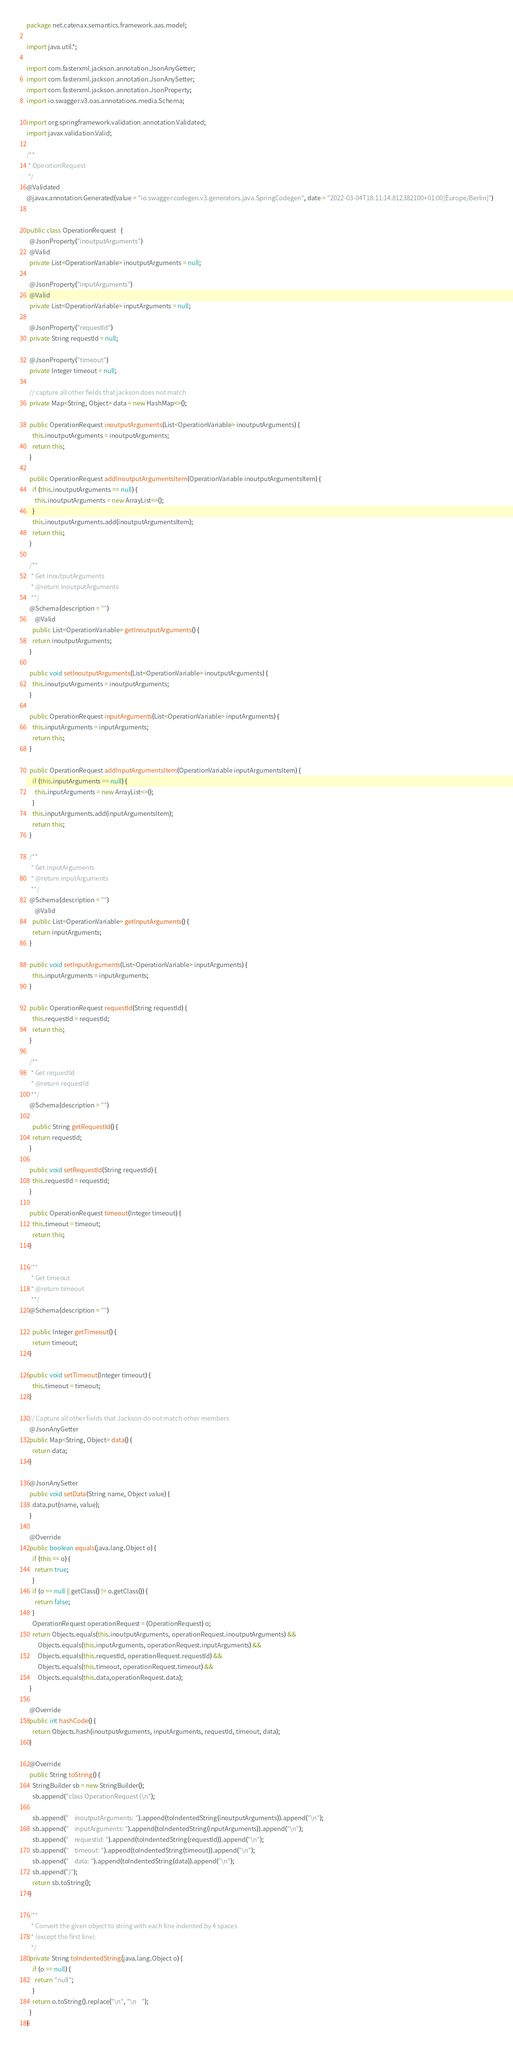Convert code to text. <code><loc_0><loc_0><loc_500><loc_500><_Java_>package net.catenax.semantics.framework.aas.model;

import java.util.*;

import com.fasterxml.jackson.annotation.JsonAnyGetter;
import com.fasterxml.jackson.annotation.JsonAnySetter;
import com.fasterxml.jackson.annotation.JsonProperty;
import io.swagger.v3.oas.annotations.media.Schema;

import org.springframework.validation.annotation.Validated;
import javax.validation.Valid;

/**
 * OperationRequest
 */
@Validated
@javax.annotation.Generated(value = "io.swagger.codegen.v3.generators.java.SpringCodegen", date = "2022-03-04T18:11:14.812382100+01:00[Europe/Berlin]")


public class OperationRequest   {
  @JsonProperty("inoutputArguments")
  @Valid
  private List<OperationVariable> inoutputArguments = null;

  @JsonProperty("inputArguments")
  @Valid
  private List<OperationVariable> inputArguments = null;

  @JsonProperty("requestId")
  private String requestId = null;

  @JsonProperty("timeout")
  private Integer timeout = null;

  // capture all other fields that jackson does not match
  private Map<String, Object> data = new HashMap<>();

  public OperationRequest inoutputArguments(List<OperationVariable> inoutputArguments) {
    this.inoutputArguments = inoutputArguments;
    return this;
  }

  public OperationRequest addInoutputArgumentsItem(OperationVariable inoutputArgumentsItem) {
    if (this.inoutputArguments == null) {
      this.inoutputArguments = new ArrayList<>();
    }
    this.inoutputArguments.add(inoutputArgumentsItem);
    return this;
  }

  /**
   * Get inoutputArguments
   * @return inoutputArguments
   **/
  @Schema(description = "")
      @Valid
    public List<OperationVariable> getInoutputArguments() {
    return inoutputArguments;
  }

  public void setInoutputArguments(List<OperationVariable> inoutputArguments) {
    this.inoutputArguments = inoutputArguments;
  }

  public OperationRequest inputArguments(List<OperationVariable> inputArguments) {
    this.inputArguments = inputArguments;
    return this;
  }

  public OperationRequest addInputArgumentsItem(OperationVariable inputArgumentsItem) {
    if (this.inputArguments == null) {
      this.inputArguments = new ArrayList<>();
    }
    this.inputArguments.add(inputArgumentsItem);
    return this;
  }

  /**
   * Get inputArguments
   * @return inputArguments
   **/
  @Schema(description = "")
      @Valid
    public List<OperationVariable> getInputArguments() {
    return inputArguments;
  }

  public void setInputArguments(List<OperationVariable> inputArguments) {
    this.inputArguments = inputArguments;
  }

  public OperationRequest requestId(String requestId) {
    this.requestId = requestId;
    return this;
  }

  /**
   * Get requestId
   * @return requestId
   **/
  @Schema(description = "")
  
    public String getRequestId() {
    return requestId;
  }

  public void setRequestId(String requestId) {
    this.requestId = requestId;
  }

  public OperationRequest timeout(Integer timeout) {
    this.timeout = timeout;
    return this;
  }

  /**
   * Get timeout
   * @return timeout
   **/
  @Schema(description = "")
  
    public Integer getTimeout() {
    return timeout;
  }

  public void setTimeout(Integer timeout) {
    this.timeout = timeout;
  }

  // Capture all other fields that Jackson do not match other members
  @JsonAnyGetter
  public Map<String, Object> data() {
    return data;
  }

  @JsonAnySetter
  public void setData(String name, Object value) {
    data.put(name, value);
  }

  @Override
  public boolean equals(java.lang.Object o) {
    if (this == o) {
      return true;
    }
    if (o == null || getClass() != o.getClass()) {
      return false;
    }
    OperationRequest operationRequest = (OperationRequest) o;
    return Objects.equals(this.inoutputArguments, operationRequest.inoutputArguments) &&
        Objects.equals(this.inputArguments, operationRequest.inputArguments) &&
        Objects.equals(this.requestId, operationRequest.requestId) &&
        Objects.equals(this.timeout, operationRequest.timeout) &&
        Objects.equals(this.data,operationRequest.data);
  }

  @Override
  public int hashCode() {
    return Objects.hash(inoutputArguments, inputArguments, requestId, timeout, data);
  }

  @Override
  public String toString() {
    StringBuilder sb = new StringBuilder();
    sb.append("class OperationRequest {\n");
    
    sb.append("    inoutputArguments: ").append(toIndentedString(inoutputArguments)).append("\n");
    sb.append("    inputArguments: ").append(toIndentedString(inputArguments)).append("\n");
    sb.append("    requestId: ").append(toIndentedString(requestId)).append("\n");
    sb.append("    timeout: ").append(toIndentedString(timeout)).append("\n");
    sb.append("    data: ").append(toIndentedString(data)).append("\n");
    sb.append("}");
    return sb.toString();
  }

  /**
   * Convert the given object to string with each line indented by 4 spaces
   * (except the first line).
   */
  private String toIndentedString(java.lang.Object o) {
    if (o == null) {
      return "null";
    }
    return o.toString().replace("\n", "\n    ");
  }
}
</code> 